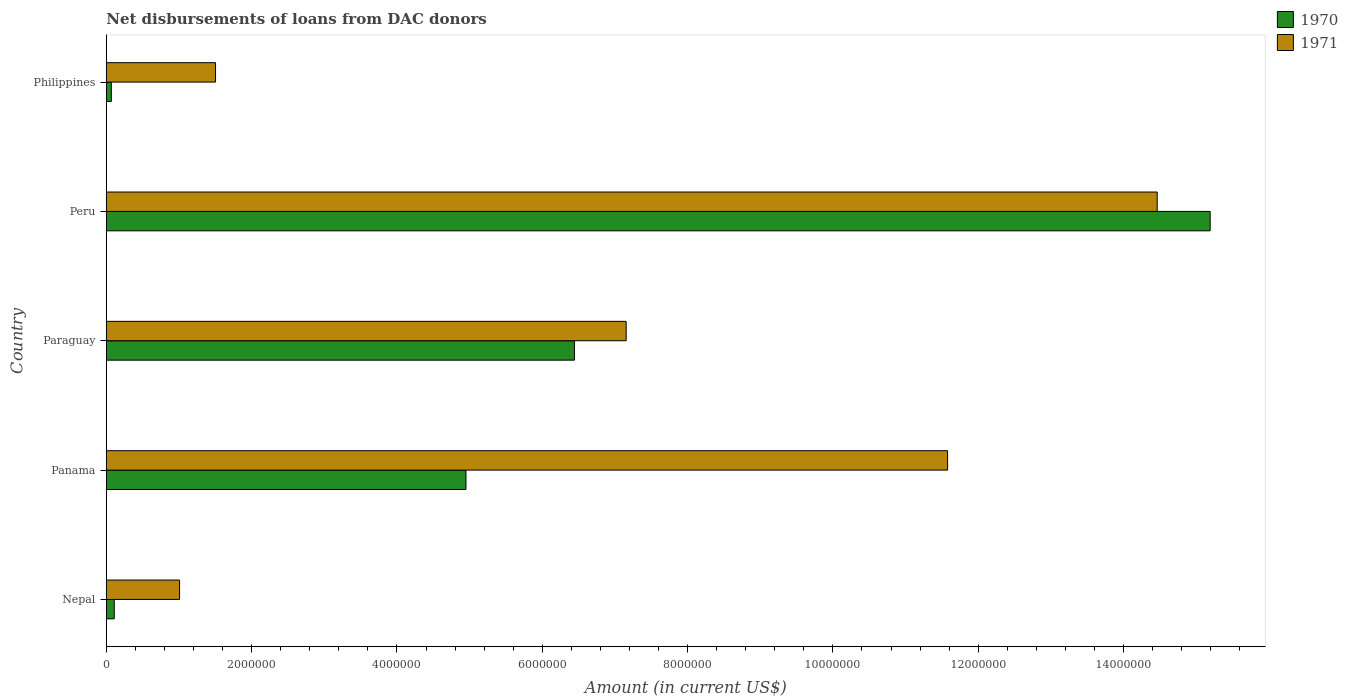Are the number of bars per tick equal to the number of legend labels?
Your response must be concise. Yes. Are the number of bars on each tick of the Y-axis equal?
Ensure brevity in your answer.  Yes. What is the label of the 5th group of bars from the top?
Give a very brief answer. Nepal. In how many cases, is the number of bars for a given country not equal to the number of legend labels?
Provide a short and direct response. 0. What is the amount of loans disbursed in 1970 in Philippines?
Your response must be concise. 6.90e+04. Across all countries, what is the maximum amount of loans disbursed in 1970?
Your answer should be very brief. 1.52e+07. Across all countries, what is the minimum amount of loans disbursed in 1971?
Keep it short and to the point. 1.01e+06. In which country was the amount of loans disbursed in 1971 maximum?
Provide a succinct answer. Peru. What is the total amount of loans disbursed in 1971 in the graph?
Provide a short and direct response. 3.57e+07. What is the difference between the amount of loans disbursed in 1970 in Nepal and that in Peru?
Offer a terse response. -1.51e+07. What is the difference between the amount of loans disbursed in 1971 in Nepal and the amount of loans disbursed in 1970 in Panama?
Give a very brief answer. -3.94e+06. What is the average amount of loans disbursed in 1970 per country?
Give a very brief answer. 5.35e+06. What is the difference between the amount of loans disbursed in 1970 and amount of loans disbursed in 1971 in Paraguay?
Provide a succinct answer. -7.12e+05. In how many countries, is the amount of loans disbursed in 1971 greater than 14400000 US$?
Make the answer very short. 1. What is the ratio of the amount of loans disbursed in 1971 in Paraguay to that in Peru?
Your answer should be compact. 0.49. What is the difference between the highest and the second highest amount of loans disbursed in 1971?
Keep it short and to the point. 2.88e+06. What is the difference between the highest and the lowest amount of loans disbursed in 1971?
Ensure brevity in your answer.  1.35e+07. In how many countries, is the amount of loans disbursed in 1970 greater than the average amount of loans disbursed in 1970 taken over all countries?
Your answer should be very brief. 2. What does the 1st bar from the top in Panama represents?
Offer a very short reply. 1971. What does the 1st bar from the bottom in Paraguay represents?
Offer a terse response. 1970. How many bars are there?
Provide a short and direct response. 10. Are all the bars in the graph horizontal?
Your answer should be compact. Yes. What is the difference between two consecutive major ticks on the X-axis?
Ensure brevity in your answer.  2.00e+06. Does the graph contain any zero values?
Make the answer very short. No. How many legend labels are there?
Ensure brevity in your answer.  2. What is the title of the graph?
Provide a short and direct response. Net disbursements of loans from DAC donors. Does "2003" appear as one of the legend labels in the graph?
Ensure brevity in your answer.  No. What is the label or title of the X-axis?
Ensure brevity in your answer.  Amount (in current US$). What is the Amount (in current US$) of 1970 in Nepal?
Offer a terse response. 1.09e+05. What is the Amount (in current US$) of 1971 in Nepal?
Make the answer very short. 1.01e+06. What is the Amount (in current US$) in 1970 in Panama?
Offer a terse response. 4.95e+06. What is the Amount (in current US$) of 1971 in Panama?
Your answer should be very brief. 1.16e+07. What is the Amount (in current US$) in 1970 in Paraguay?
Provide a short and direct response. 6.44e+06. What is the Amount (in current US$) of 1971 in Paraguay?
Ensure brevity in your answer.  7.16e+06. What is the Amount (in current US$) of 1970 in Peru?
Your answer should be very brief. 1.52e+07. What is the Amount (in current US$) of 1971 in Peru?
Offer a terse response. 1.45e+07. What is the Amount (in current US$) of 1970 in Philippines?
Offer a terse response. 6.90e+04. What is the Amount (in current US$) of 1971 in Philippines?
Provide a short and direct response. 1.50e+06. Across all countries, what is the maximum Amount (in current US$) of 1970?
Your answer should be compact. 1.52e+07. Across all countries, what is the maximum Amount (in current US$) of 1971?
Make the answer very short. 1.45e+07. Across all countries, what is the minimum Amount (in current US$) in 1970?
Your answer should be very brief. 6.90e+04. Across all countries, what is the minimum Amount (in current US$) in 1971?
Your answer should be very brief. 1.01e+06. What is the total Amount (in current US$) in 1970 in the graph?
Your answer should be compact. 2.68e+07. What is the total Amount (in current US$) of 1971 in the graph?
Ensure brevity in your answer.  3.57e+07. What is the difference between the Amount (in current US$) in 1970 in Nepal and that in Panama?
Offer a very short reply. -4.84e+06. What is the difference between the Amount (in current US$) in 1971 in Nepal and that in Panama?
Your answer should be compact. -1.06e+07. What is the difference between the Amount (in current US$) of 1970 in Nepal and that in Paraguay?
Provide a succinct answer. -6.33e+06. What is the difference between the Amount (in current US$) of 1971 in Nepal and that in Paraguay?
Keep it short and to the point. -6.15e+06. What is the difference between the Amount (in current US$) in 1970 in Nepal and that in Peru?
Offer a very short reply. -1.51e+07. What is the difference between the Amount (in current US$) of 1971 in Nepal and that in Peru?
Provide a succinct answer. -1.35e+07. What is the difference between the Amount (in current US$) of 1971 in Nepal and that in Philippines?
Offer a terse response. -4.95e+05. What is the difference between the Amount (in current US$) of 1970 in Panama and that in Paraguay?
Offer a terse response. -1.49e+06. What is the difference between the Amount (in current US$) of 1971 in Panama and that in Paraguay?
Give a very brief answer. 4.42e+06. What is the difference between the Amount (in current US$) of 1970 in Panama and that in Peru?
Your response must be concise. -1.02e+07. What is the difference between the Amount (in current US$) in 1971 in Panama and that in Peru?
Your answer should be compact. -2.88e+06. What is the difference between the Amount (in current US$) in 1970 in Panama and that in Philippines?
Ensure brevity in your answer.  4.88e+06. What is the difference between the Amount (in current US$) in 1971 in Panama and that in Philippines?
Give a very brief answer. 1.01e+07. What is the difference between the Amount (in current US$) of 1970 in Paraguay and that in Peru?
Offer a very short reply. -8.75e+06. What is the difference between the Amount (in current US$) in 1971 in Paraguay and that in Peru?
Your answer should be compact. -7.31e+06. What is the difference between the Amount (in current US$) of 1970 in Paraguay and that in Philippines?
Your answer should be very brief. 6.37e+06. What is the difference between the Amount (in current US$) in 1971 in Paraguay and that in Philippines?
Make the answer very short. 5.65e+06. What is the difference between the Amount (in current US$) in 1970 in Peru and that in Philippines?
Keep it short and to the point. 1.51e+07. What is the difference between the Amount (in current US$) in 1971 in Peru and that in Philippines?
Your answer should be compact. 1.30e+07. What is the difference between the Amount (in current US$) in 1970 in Nepal and the Amount (in current US$) in 1971 in Panama?
Your answer should be very brief. -1.15e+07. What is the difference between the Amount (in current US$) of 1970 in Nepal and the Amount (in current US$) of 1971 in Paraguay?
Provide a succinct answer. -7.05e+06. What is the difference between the Amount (in current US$) of 1970 in Nepal and the Amount (in current US$) of 1971 in Peru?
Offer a terse response. -1.44e+07. What is the difference between the Amount (in current US$) in 1970 in Nepal and the Amount (in current US$) in 1971 in Philippines?
Offer a terse response. -1.39e+06. What is the difference between the Amount (in current US$) of 1970 in Panama and the Amount (in current US$) of 1971 in Paraguay?
Ensure brevity in your answer.  -2.20e+06. What is the difference between the Amount (in current US$) in 1970 in Panama and the Amount (in current US$) in 1971 in Peru?
Your answer should be very brief. -9.51e+06. What is the difference between the Amount (in current US$) of 1970 in Panama and the Amount (in current US$) of 1971 in Philippines?
Provide a short and direct response. 3.45e+06. What is the difference between the Amount (in current US$) of 1970 in Paraguay and the Amount (in current US$) of 1971 in Peru?
Give a very brief answer. -8.02e+06. What is the difference between the Amount (in current US$) in 1970 in Paraguay and the Amount (in current US$) in 1971 in Philippines?
Keep it short and to the point. 4.94e+06. What is the difference between the Amount (in current US$) of 1970 in Peru and the Amount (in current US$) of 1971 in Philippines?
Offer a terse response. 1.37e+07. What is the average Amount (in current US$) in 1970 per country?
Keep it short and to the point. 5.35e+06. What is the average Amount (in current US$) in 1971 per country?
Your response must be concise. 7.14e+06. What is the difference between the Amount (in current US$) in 1970 and Amount (in current US$) in 1971 in Nepal?
Your answer should be compact. -8.99e+05. What is the difference between the Amount (in current US$) in 1970 and Amount (in current US$) in 1971 in Panama?
Give a very brief answer. -6.63e+06. What is the difference between the Amount (in current US$) in 1970 and Amount (in current US$) in 1971 in Paraguay?
Provide a short and direct response. -7.12e+05. What is the difference between the Amount (in current US$) in 1970 and Amount (in current US$) in 1971 in Peru?
Offer a very short reply. 7.29e+05. What is the difference between the Amount (in current US$) of 1970 and Amount (in current US$) of 1971 in Philippines?
Give a very brief answer. -1.43e+06. What is the ratio of the Amount (in current US$) in 1970 in Nepal to that in Panama?
Offer a terse response. 0.02. What is the ratio of the Amount (in current US$) of 1971 in Nepal to that in Panama?
Offer a terse response. 0.09. What is the ratio of the Amount (in current US$) of 1970 in Nepal to that in Paraguay?
Make the answer very short. 0.02. What is the ratio of the Amount (in current US$) of 1971 in Nepal to that in Paraguay?
Keep it short and to the point. 0.14. What is the ratio of the Amount (in current US$) in 1970 in Nepal to that in Peru?
Give a very brief answer. 0.01. What is the ratio of the Amount (in current US$) in 1971 in Nepal to that in Peru?
Your answer should be very brief. 0.07. What is the ratio of the Amount (in current US$) in 1970 in Nepal to that in Philippines?
Keep it short and to the point. 1.58. What is the ratio of the Amount (in current US$) of 1971 in Nepal to that in Philippines?
Make the answer very short. 0.67. What is the ratio of the Amount (in current US$) in 1970 in Panama to that in Paraguay?
Your response must be concise. 0.77. What is the ratio of the Amount (in current US$) of 1971 in Panama to that in Paraguay?
Your answer should be compact. 1.62. What is the ratio of the Amount (in current US$) of 1970 in Panama to that in Peru?
Your response must be concise. 0.33. What is the ratio of the Amount (in current US$) of 1971 in Panama to that in Peru?
Your answer should be very brief. 0.8. What is the ratio of the Amount (in current US$) of 1970 in Panama to that in Philippines?
Keep it short and to the point. 71.74. What is the ratio of the Amount (in current US$) in 1971 in Panama to that in Philippines?
Give a very brief answer. 7.7. What is the ratio of the Amount (in current US$) in 1970 in Paraguay to that in Peru?
Provide a succinct answer. 0.42. What is the ratio of the Amount (in current US$) in 1971 in Paraguay to that in Peru?
Keep it short and to the point. 0.49. What is the ratio of the Amount (in current US$) of 1970 in Paraguay to that in Philippines?
Give a very brief answer. 93.38. What is the ratio of the Amount (in current US$) of 1971 in Paraguay to that in Philippines?
Give a very brief answer. 4.76. What is the ratio of the Amount (in current US$) in 1970 in Peru to that in Philippines?
Give a very brief answer. 220.19. What is the ratio of the Amount (in current US$) in 1971 in Peru to that in Philippines?
Your answer should be compact. 9.62. What is the difference between the highest and the second highest Amount (in current US$) in 1970?
Your response must be concise. 8.75e+06. What is the difference between the highest and the second highest Amount (in current US$) in 1971?
Ensure brevity in your answer.  2.88e+06. What is the difference between the highest and the lowest Amount (in current US$) in 1970?
Make the answer very short. 1.51e+07. What is the difference between the highest and the lowest Amount (in current US$) in 1971?
Your answer should be compact. 1.35e+07. 